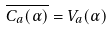Convert formula to latex. <formula><loc_0><loc_0><loc_500><loc_500>\overline { C _ { a } ( \alpha ) } = V _ { a } ( \alpha )</formula> 